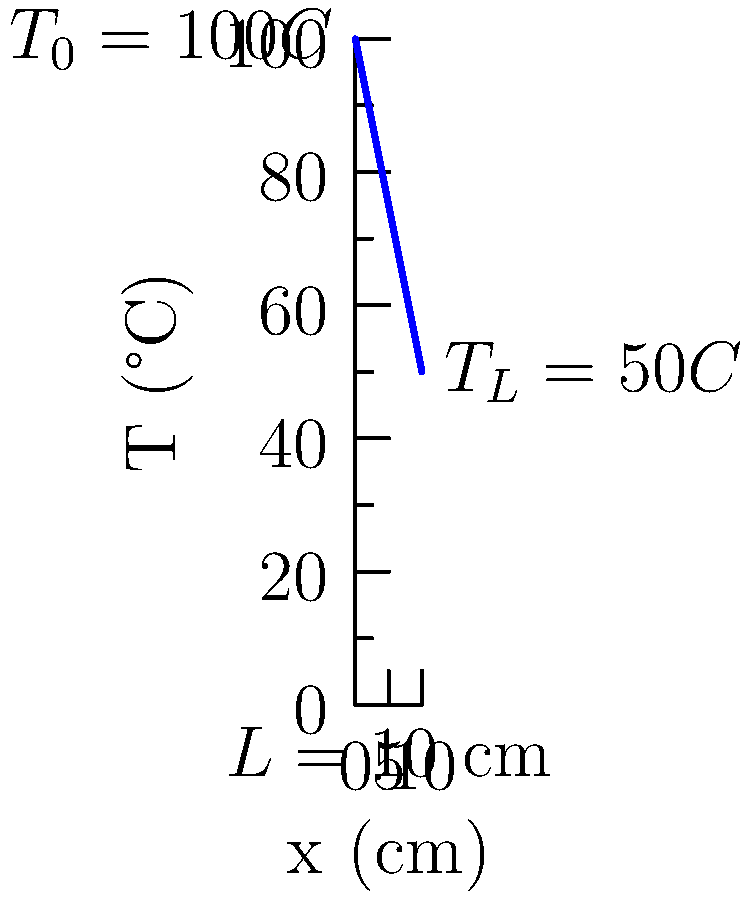Consider a heat-conducting rod of length $L = 10$ cm with thermal conductivity $k = 0.5$ W/(cm·°C) and cross-sectional area $A = 2$ cm². The temperature at the left end ($x = 0$) is maintained at $T_0 = 100°C$, while the right end ($x = L$) is kept at $T_L = 50°C$. Assuming steady-state conditions and no internal heat generation, determine the heat flux $q$ (in W/cm²) through the rod. To solve this problem, we'll follow these steps:

1) In steady-state conditions with no internal heat generation, the heat equation reduces to:

   $$\frac{d^2T}{dx^2} = 0$$

2) The general solution to this equation is:

   $$T(x) = C_1x + C_2$$

3) Using the boundary conditions:
   At $x = 0$, $T = T_0 = 100°C$
   At $x = L = 10$ cm, $T = T_L = 50°C$

4) Applying these conditions:
   $$T_0 = C_2 = 100°C$$
   $$T_L = C_1L + C_2 \implies 50 = 10C_1 + 100 \implies C_1 = -5°C/cm$$

5) The temperature distribution is thus:
   $$T(x) = -5x + 100$$

6) The heat flux is given by Fourier's law:
   $$q = -k\frac{dT}{dx}$$

7) Differentiating $T(x)$:
   $$\frac{dT}{dx} = -5°C/cm$$

8) Substituting into Fourier's law:
   $$q = -k\frac{dT}{dx} = -(0.5 \text{ W/(cm·°C)})(-5°C/cm) = 2.5 \text{ W/cm²}$$

Therefore, the heat flux through the rod is 2.5 W/cm².
Answer: 2.5 W/cm² 